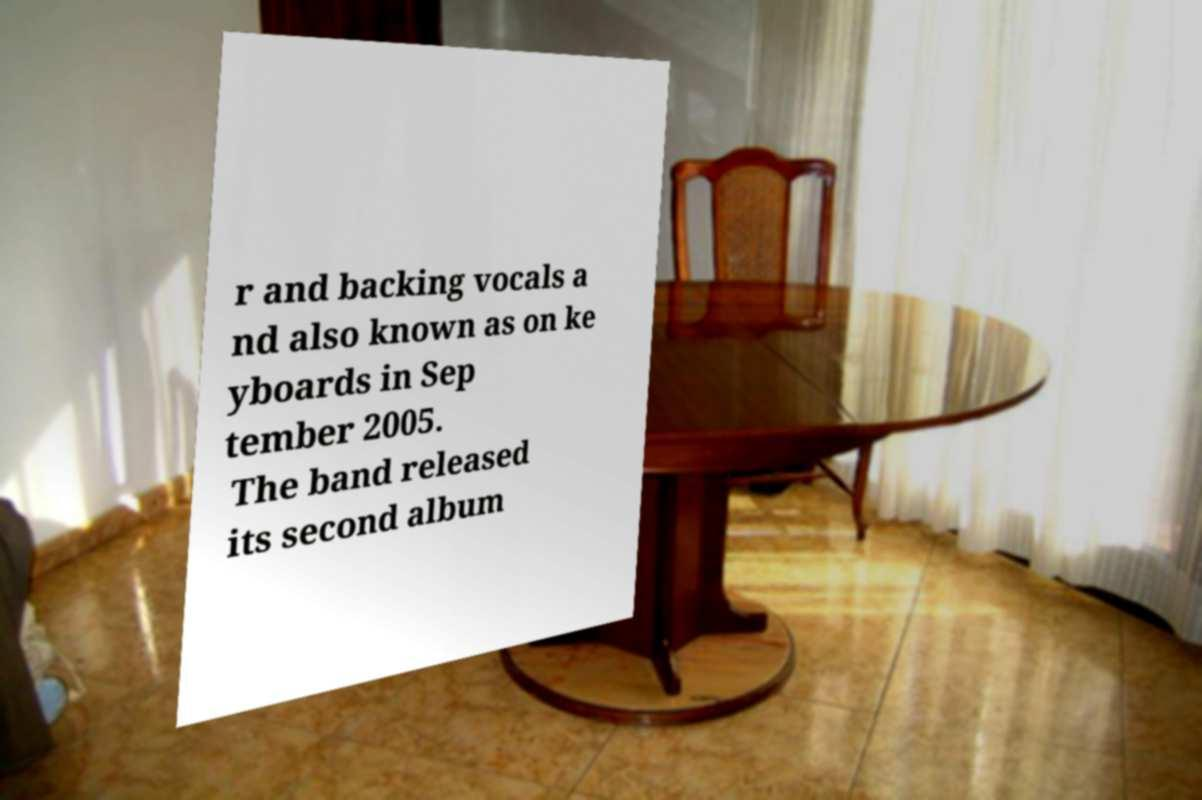Could you assist in decoding the text presented in this image and type it out clearly? r and backing vocals a nd also known as on ke yboards in Sep tember 2005. The band released its second album 